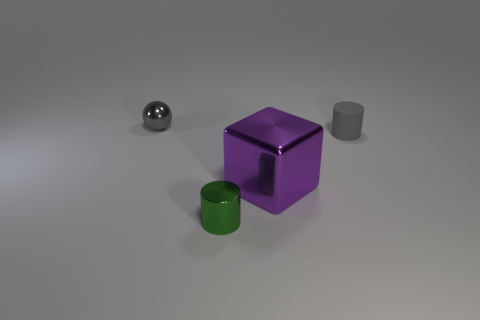Add 3 rubber things. How many objects exist? 7 Subtract all balls. How many objects are left? 3 Add 3 small gray metal objects. How many small gray metal objects exist? 4 Subtract 0 yellow cylinders. How many objects are left? 4 Subtract all things. Subtract all brown shiny cylinders. How many objects are left? 0 Add 1 green things. How many green things are left? 2 